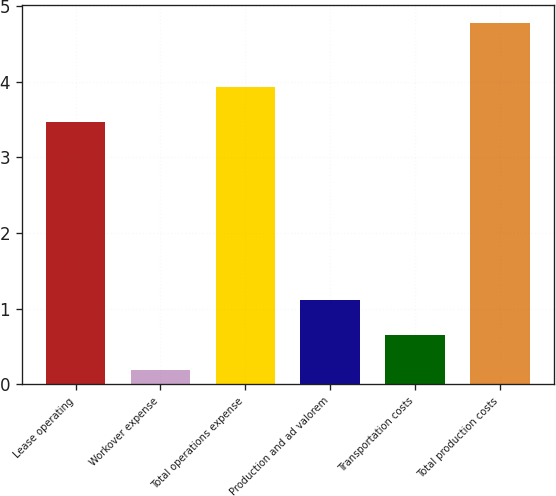Convert chart to OTSL. <chart><loc_0><loc_0><loc_500><loc_500><bar_chart><fcel>Lease operating<fcel>Workover expense<fcel>Total operations expense<fcel>Production and ad valorem<fcel>Transportation costs<fcel>Total production costs<nl><fcel>3.47<fcel>0.19<fcel>3.93<fcel>1.11<fcel>0.65<fcel>4.78<nl></chart> 